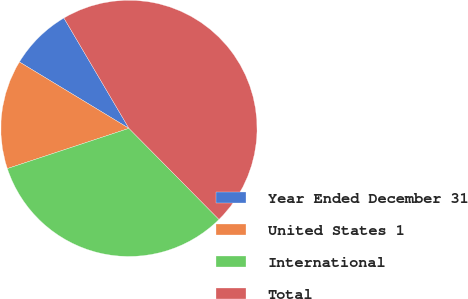Convert chart. <chart><loc_0><loc_0><loc_500><loc_500><pie_chart><fcel>Year Ended December 31<fcel>United States 1<fcel>International<fcel>Total<nl><fcel>7.85%<fcel>13.76%<fcel>32.32%<fcel>46.07%<nl></chart> 